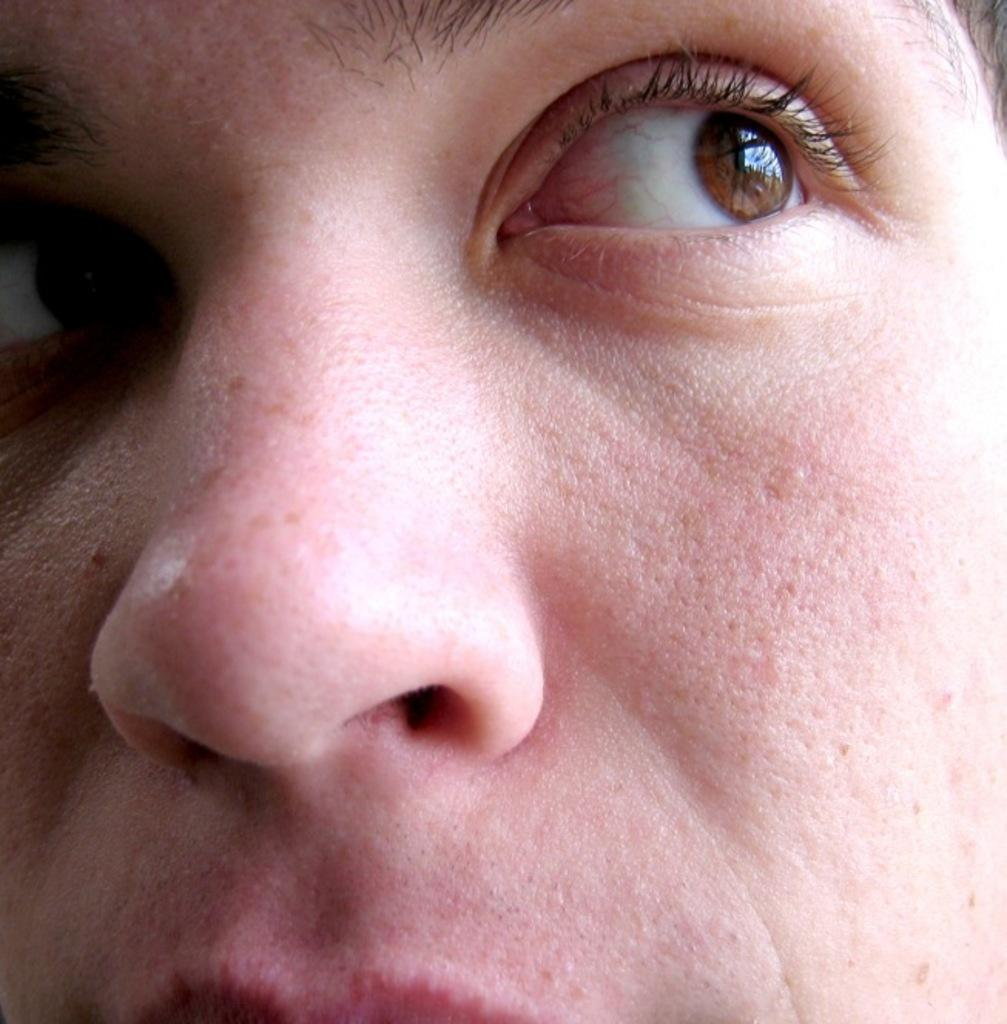What is the main subject of the image? There is a person's face in the image. How many ants can be seen crawling on the woman's face in the image? There is no woman or ants present in the image; it only features a person's face. 